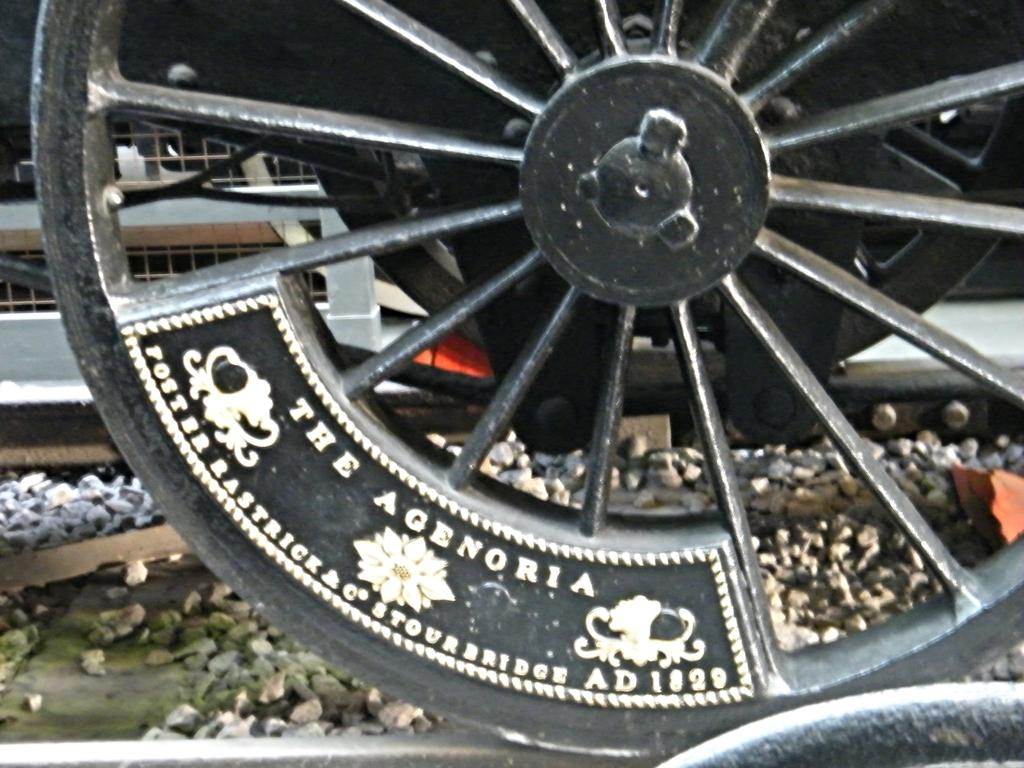<image>
Create a compact narrative representing the image presented. A wheel on which the date 1929 is visible. 